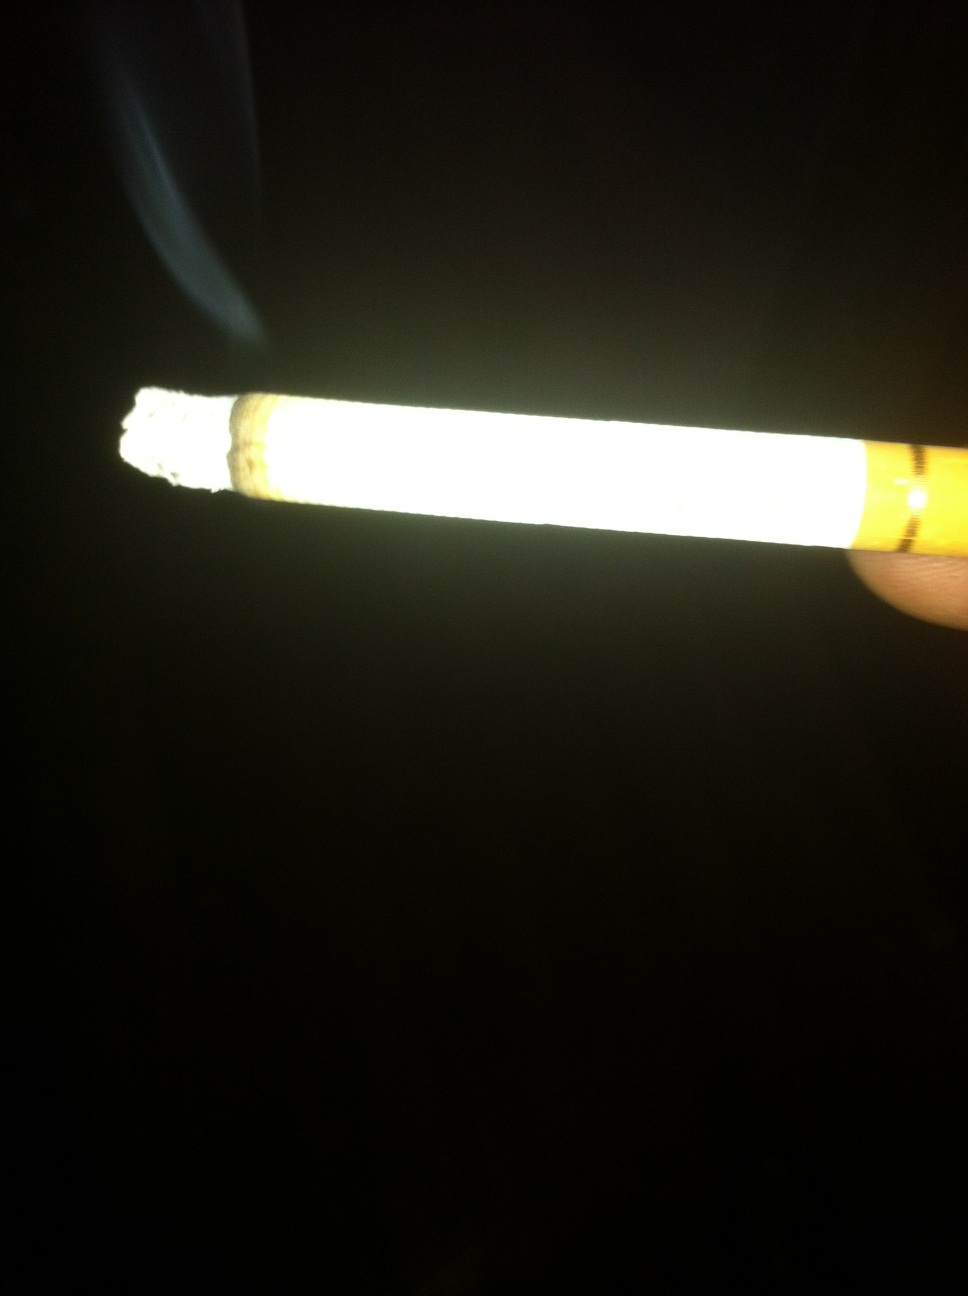Why might this image be significant in social or cultural discussions? This image can be significant in discussions about smoking as a societal issue, touching on topics like addiction, public health policy, the influence of tobacco advertising, and the cultural shift towards smoking restrictions and cessation efforts. 